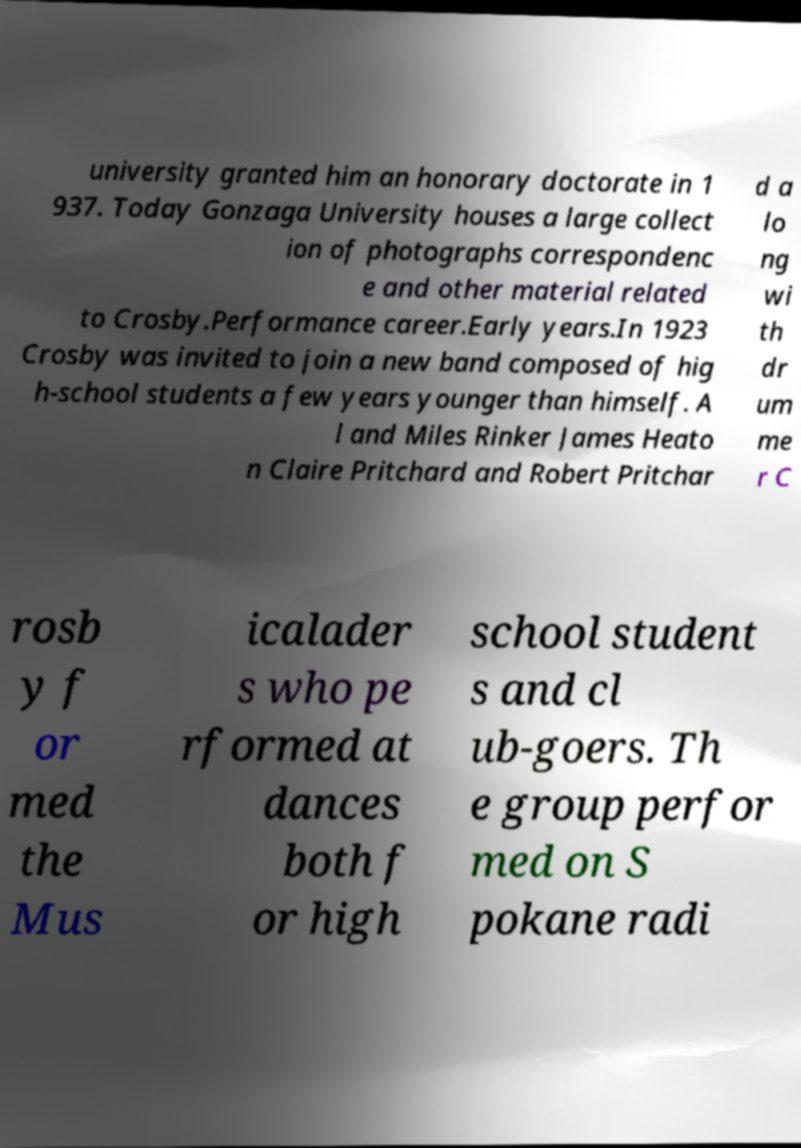Could you extract and type out the text from this image? university granted him an honorary doctorate in 1 937. Today Gonzaga University houses a large collect ion of photographs correspondenc e and other material related to Crosby.Performance career.Early years.In 1923 Crosby was invited to join a new band composed of hig h-school students a few years younger than himself. A l and Miles Rinker James Heato n Claire Pritchard and Robert Pritchar d a lo ng wi th dr um me r C rosb y f or med the Mus icalader s who pe rformed at dances both f or high school student s and cl ub-goers. Th e group perfor med on S pokane radi 